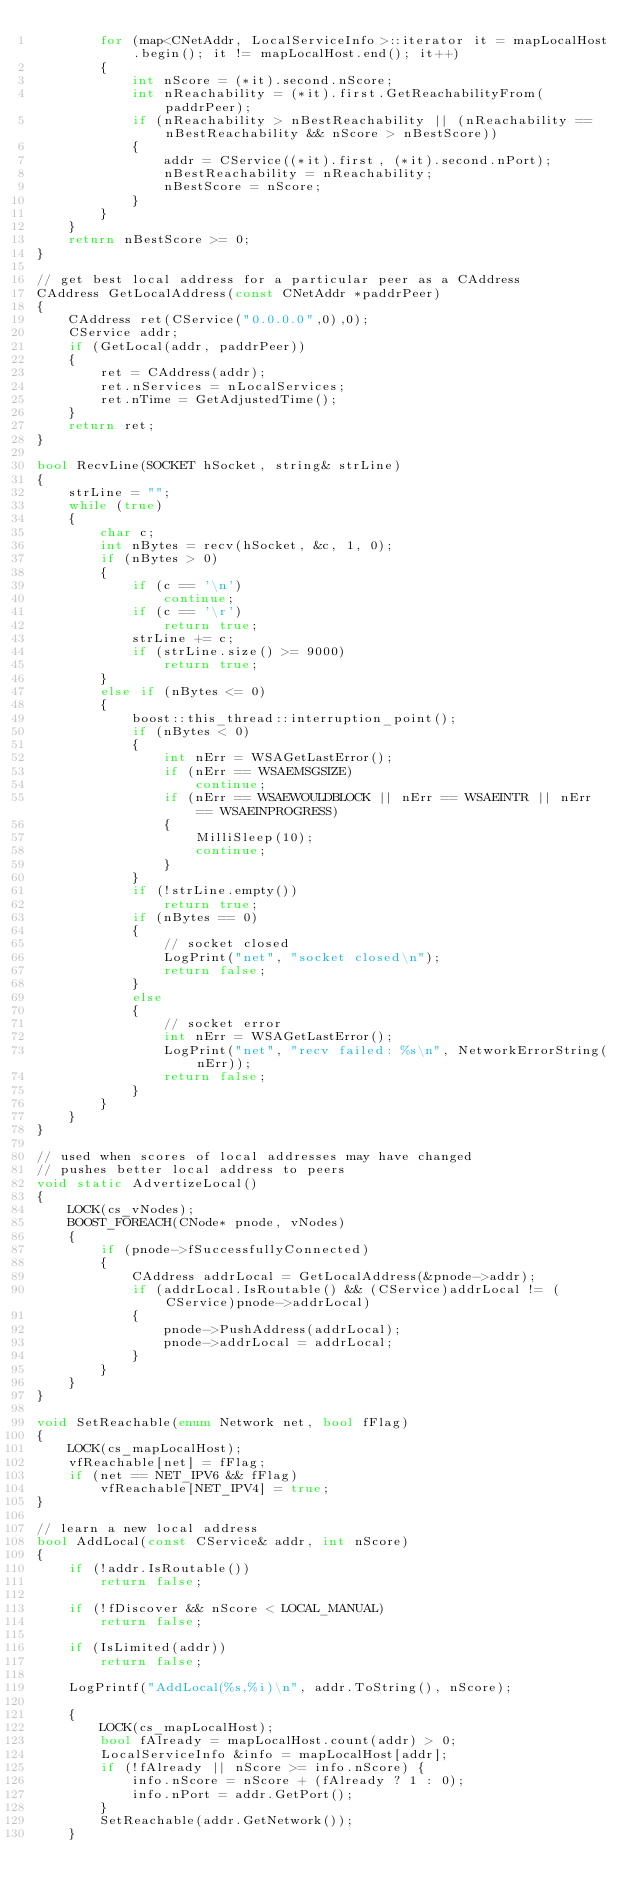<code> <loc_0><loc_0><loc_500><loc_500><_C++_>        for (map<CNetAddr, LocalServiceInfo>::iterator it = mapLocalHost.begin(); it != mapLocalHost.end(); it++)
        {
            int nScore = (*it).second.nScore;
            int nReachability = (*it).first.GetReachabilityFrom(paddrPeer);
            if (nReachability > nBestReachability || (nReachability == nBestReachability && nScore > nBestScore))
            {
                addr = CService((*it).first, (*it).second.nPort);
                nBestReachability = nReachability;
                nBestScore = nScore;
            }
        }
    }
    return nBestScore >= 0;
}

// get best local address for a particular peer as a CAddress
CAddress GetLocalAddress(const CNetAddr *paddrPeer)
{
    CAddress ret(CService("0.0.0.0",0),0);
    CService addr;
    if (GetLocal(addr, paddrPeer))
    {
        ret = CAddress(addr);
        ret.nServices = nLocalServices;
        ret.nTime = GetAdjustedTime();
    }
    return ret;
}

bool RecvLine(SOCKET hSocket, string& strLine)
{
    strLine = "";
    while (true)
    {
        char c;
        int nBytes = recv(hSocket, &c, 1, 0);
        if (nBytes > 0)
        {
            if (c == '\n')
                continue;
            if (c == '\r')
                return true;
            strLine += c;
            if (strLine.size() >= 9000)
                return true;
        }
        else if (nBytes <= 0)
        {
            boost::this_thread::interruption_point();
            if (nBytes < 0)
            {
                int nErr = WSAGetLastError();
                if (nErr == WSAEMSGSIZE)
                    continue;
                if (nErr == WSAEWOULDBLOCK || nErr == WSAEINTR || nErr == WSAEINPROGRESS)
                {
                    MilliSleep(10);
                    continue;
                }
            }
            if (!strLine.empty())
                return true;
            if (nBytes == 0)
            {
                // socket closed
                LogPrint("net", "socket closed\n");
                return false;
            }
            else
            {
                // socket error
                int nErr = WSAGetLastError();
                LogPrint("net", "recv failed: %s\n", NetworkErrorString(nErr));
                return false;
            }
        }
    }
}

// used when scores of local addresses may have changed
// pushes better local address to peers
void static AdvertizeLocal()
{
    LOCK(cs_vNodes);
    BOOST_FOREACH(CNode* pnode, vNodes)
    {
        if (pnode->fSuccessfullyConnected)
        {
            CAddress addrLocal = GetLocalAddress(&pnode->addr);
            if (addrLocal.IsRoutable() && (CService)addrLocal != (CService)pnode->addrLocal)
            {
                pnode->PushAddress(addrLocal);
                pnode->addrLocal = addrLocal;
            }
        }
    }
}

void SetReachable(enum Network net, bool fFlag)
{
    LOCK(cs_mapLocalHost);
    vfReachable[net] = fFlag;
    if (net == NET_IPV6 && fFlag)
        vfReachable[NET_IPV4] = true;
}

// learn a new local address
bool AddLocal(const CService& addr, int nScore)
{
    if (!addr.IsRoutable())
        return false;

    if (!fDiscover && nScore < LOCAL_MANUAL)
        return false;

    if (IsLimited(addr))
        return false;

    LogPrintf("AddLocal(%s,%i)\n", addr.ToString(), nScore);

    {
        LOCK(cs_mapLocalHost);
        bool fAlready = mapLocalHost.count(addr) > 0;
        LocalServiceInfo &info = mapLocalHost[addr];
        if (!fAlready || nScore >= info.nScore) {
            info.nScore = nScore + (fAlready ? 1 : 0);
            info.nPort = addr.GetPort();
        }
        SetReachable(addr.GetNetwork());
    }
</code> 